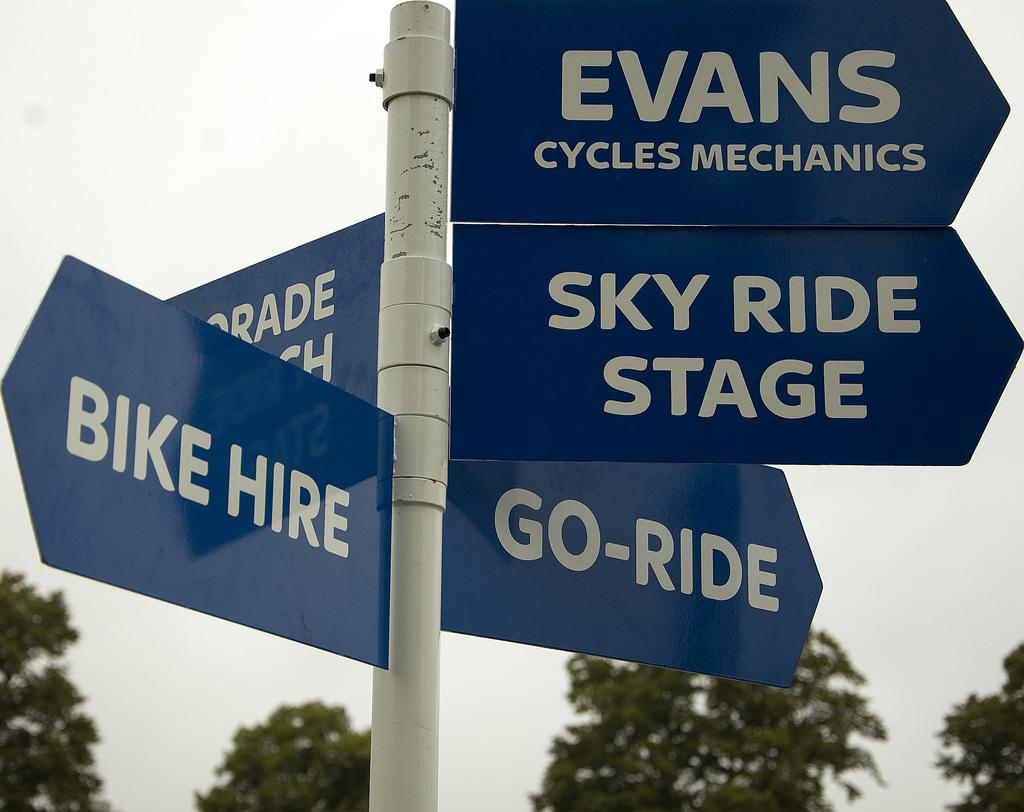<image>
Provide a brief description of the given image. A cluster of directional signage for things like the bike hire and go ride. 